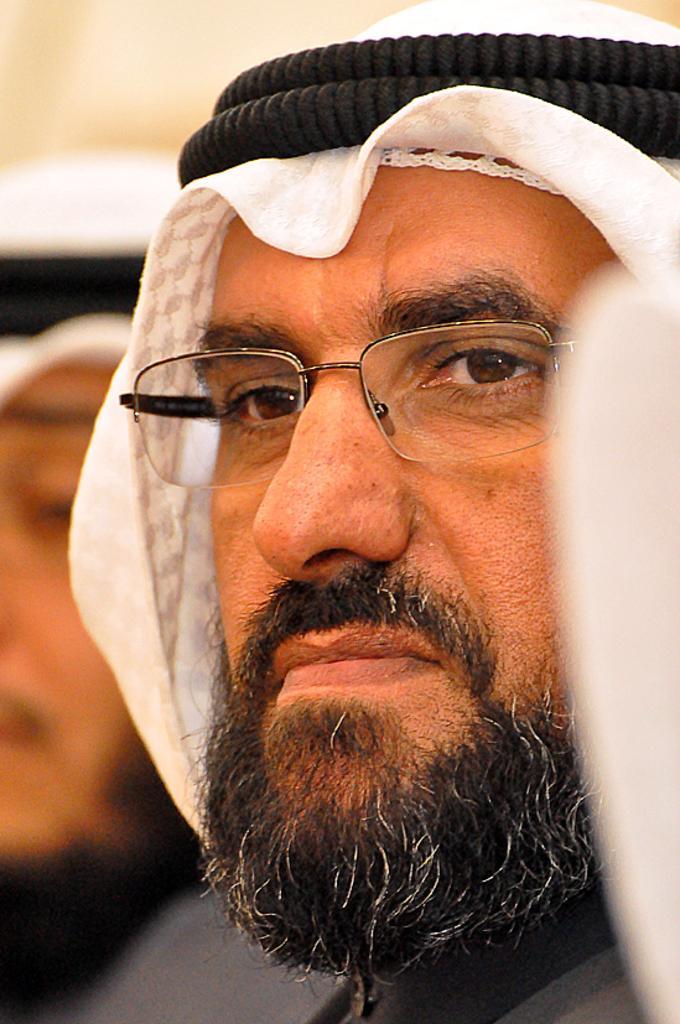How would you summarize this image in a sentence or two? In this image we can see two persons, among them one person is wearing spectacles and the background looks like the wall. 